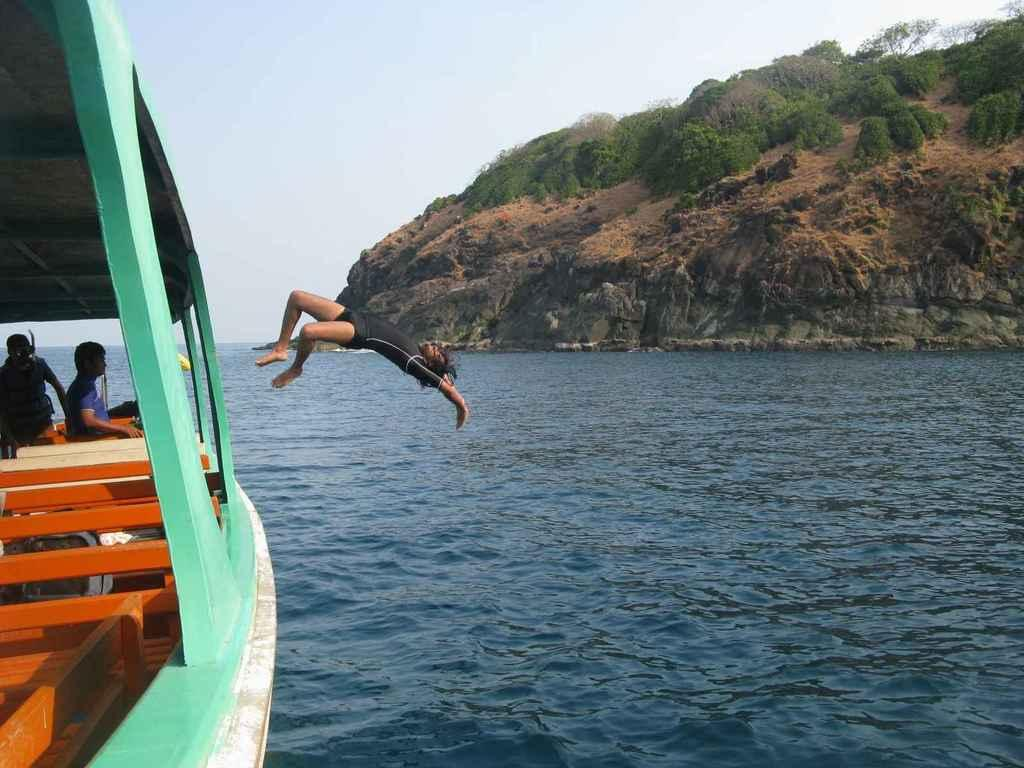What are the people in the image doing? There are persons standing in a boat, and one person is jumping into the water. What can be seen in the background of the image? There are hills, trees, and the sky visible in the background of the image. How many boats are visible in the image? There is only one boat visible in the image, as stated in the fact that there are persons standing in a boat. 